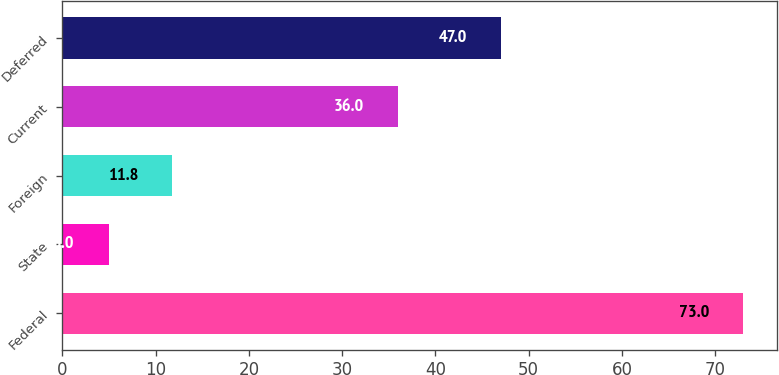<chart> <loc_0><loc_0><loc_500><loc_500><bar_chart><fcel>Federal<fcel>State<fcel>Foreign<fcel>Current<fcel>Deferred<nl><fcel>73<fcel>5<fcel>11.8<fcel>36<fcel>47<nl></chart> 